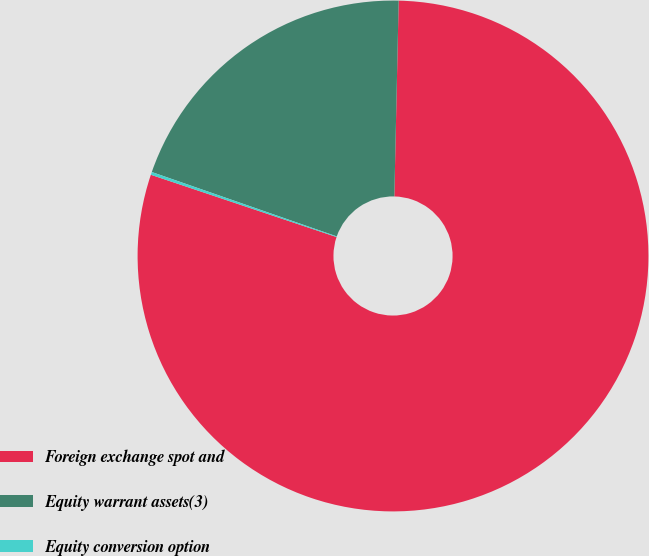Convert chart to OTSL. <chart><loc_0><loc_0><loc_500><loc_500><pie_chart><fcel>Foreign exchange spot and<fcel>Equity warrant assets(3)<fcel>Equity conversion option<nl><fcel>79.79%<fcel>20.02%<fcel>0.18%<nl></chart> 